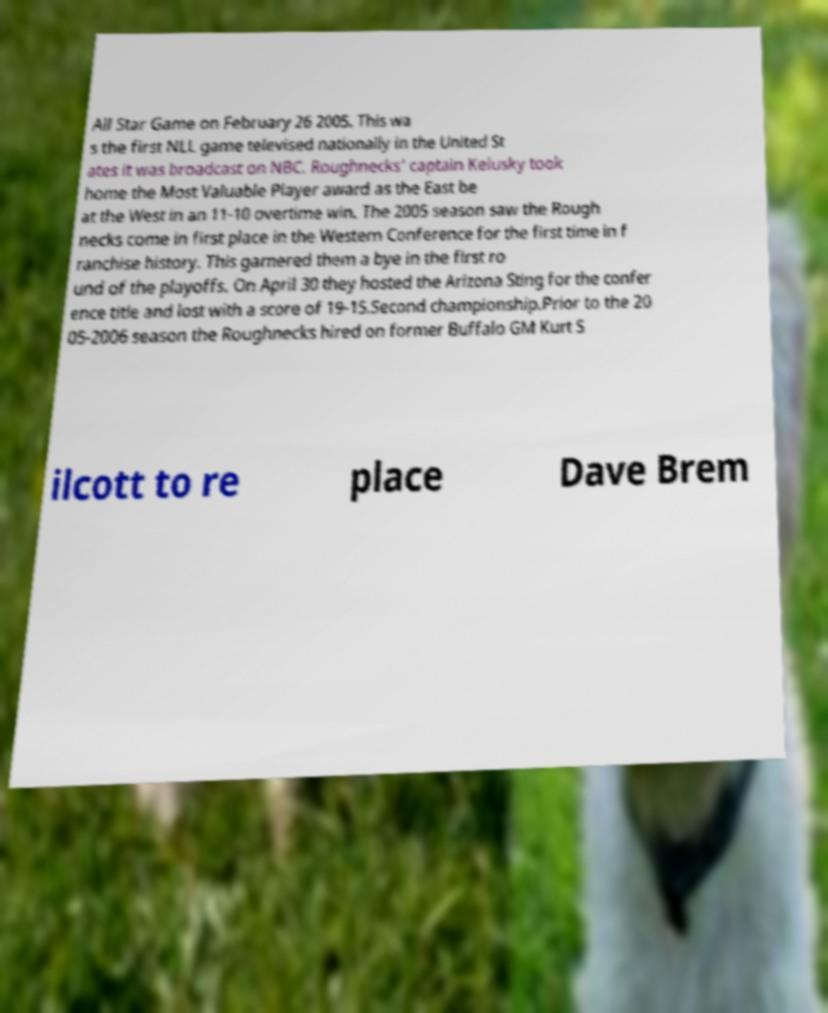I need the written content from this picture converted into text. Can you do that? All Star Game on February 26 2005. This wa s the first NLL game televised nationally in the United St ates it was broadcast on NBC. Roughnecks' captain Kelusky took home the Most Valuable Player award as the East be at the West in an 11-10 overtime win. The 2005 season saw the Rough necks come in first place in the Western Conference for the first time in f ranchise history. This garnered them a bye in the first ro und of the playoffs. On April 30 they hosted the Arizona Sting for the confer ence title and lost with a score of 19-15.Second championship.Prior to the 20 05-2006 season the Roughnecks hired on former Buffalo GM Kurt S ilcott to re place Dave Brem 